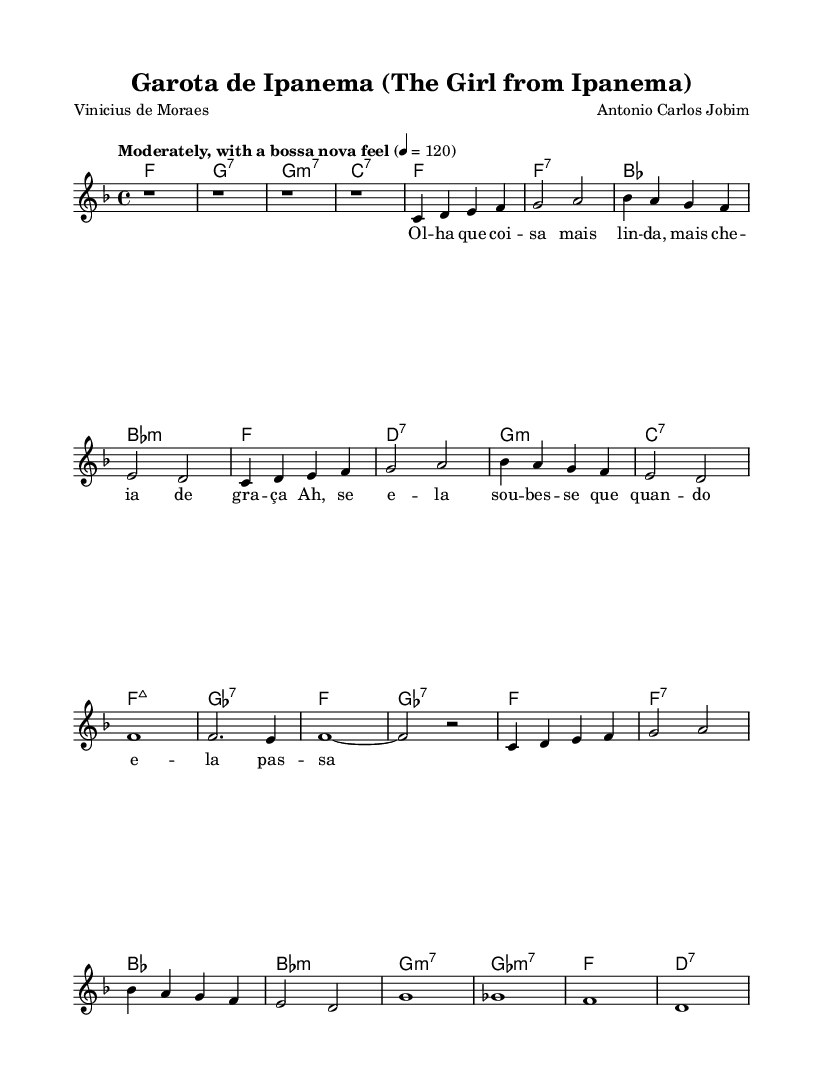What is the key signature of this music? The key signature is F major, which is indicated by one flat (B flat).
Answer: F major What is the time signature of this music? The time signature is 4/4, meaning there are four beats in each measure.
Answer: 4/4 What is the tempo marking for this piece? The tempo marking is "Moderately, with a bossa nova feel," which guides the performer to play at a moderate speed with a specific rhythmic style.
Answer: Moderately, with a bossa nova feel How many measures are in the chorus section? The chorus consists of 4 measures; this can be counted from the note sections where the choruses are marked.
Answer: 4 What is the first chord in the song? The first chord is F major, as indicated at the beginning of the score in the chord line.
Answer: F What type of song is this based on its characteristics? This song represents a bossa nova style, a genre that fuses samba and jazz, and the format indicates it is a folk adaptation of a well-known Brazilian song.
Answer: Bossa nova What are the lyrics to the first line of the verse? The first line of the verse is "Olha que coisa mais linda, mais cheia de graça," which gives a glimpse of the song's theme and sentiment.
Answer: Olha que coisa mais linda, mais cheia de graça 